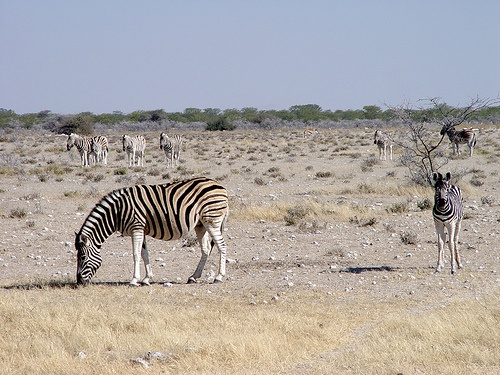Describe the objects in this image and their specific colors. I can see zebra in darkgray, black, ivory, and gray tones, zebra in darkgray, black, gray, and lightgray tones, zebra in darkgray, lightgray, and gray tones, zebra in darkgray, lightgray, gray, and black tones, and zebra in darkgray, gray, lightgray, and black tones in this image. 